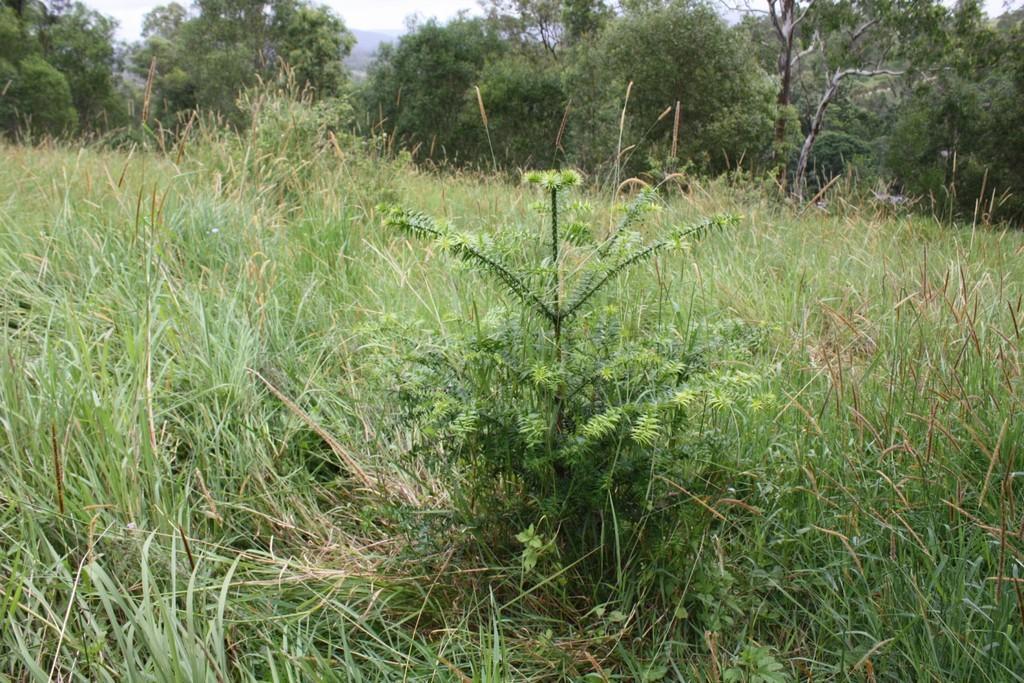What type of vegetation is in the front of the image? There is grass in the front of the image. What can be seen in the background of the image? There are trees in the background of the image. Can you describe the object visible in the background? Unfortunately, the facts provided do not give enough information to describe the object in the background. What type of bomb is being used in the feast depicted in the image? There is no feast or bomb present in the image; it features grass in the front and trees in the background. How many men are visible in the image? There is no mention of men in the provided facts, so we cannot determine the number of men present in the image. 